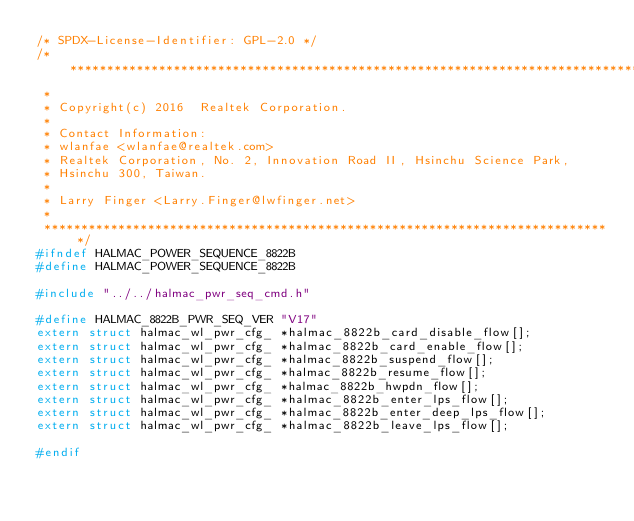<code> <loc_0><loc_0><loc_500><loc_500><_C_>/* SPDX-License-Identifier: GPL-2.0 */
/******************************************************************************
 *
 * Copyright(c) 2016  Realtek Corporation.
 *
 * Contact Information:
 * wlanfae <wlanfae@realtek.com>
 * Realtek Corporation, No. 2, Innovation Road II, Hsinchu Science Park,
 * Hsinchu 300, Taiwan.
 *
 * Larry Finger <Larry.Finger@lwfinger.net>
 *
 *****************************************************************************/
#ifndef HALMAC_POWER_SEQUENCE_8822B
#define HALMAC_POWER_SEQUENCE_8822B

#include "../../halmac_pwr_seq_cmd.h"

#define HALMAC_8822B_PWR_SEQ_VER "V17"
extern struct halmac_wl_pwr_cfg_ *halmac_8822b_card_disable_flow[];
extern struct halmac_wl_pwr_cfg_ *halmac_8822b_card_enable_flow[];
extern struct halmac_wl_pwr_cfg_ *halmac_8822b_suspend_flow[];
extern struct halmac_wl_pwr_cfg_ *halmac_8822b_resume_flow[];
extern struct halmac_wl_pwr_cfg_ *halmac_8822b_hwpdn_flow[];
extern struct halmac_wl_pwr_cfg_ *halmac_8822b_enter_lps_flow[];
extern struct halmac_wl_pwr_cfg_ *halmac_8822b_enter_deep_lps_flow[];
extern struct halmac_wl_pwr_cfg_ *halmac_8822b_leave_lps_flow[];

#endif
</code> 